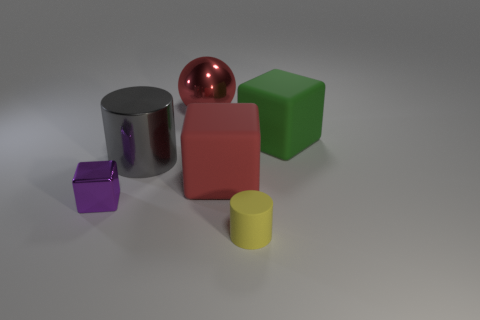Add 2 big red objects. How many objects exist? 8 Subtract all balls. How many objects are left? 5 Subtract all red rubber objects. Subtract all metal objects. How many objects are left? 2 Add 1 metallic objects. How many metallic objects are left? 4 Add 4 blue rubber cubes. How many blue rubber cubes exist? 4 Subtract 1 yellow cylinders. How many objects are left? 5 